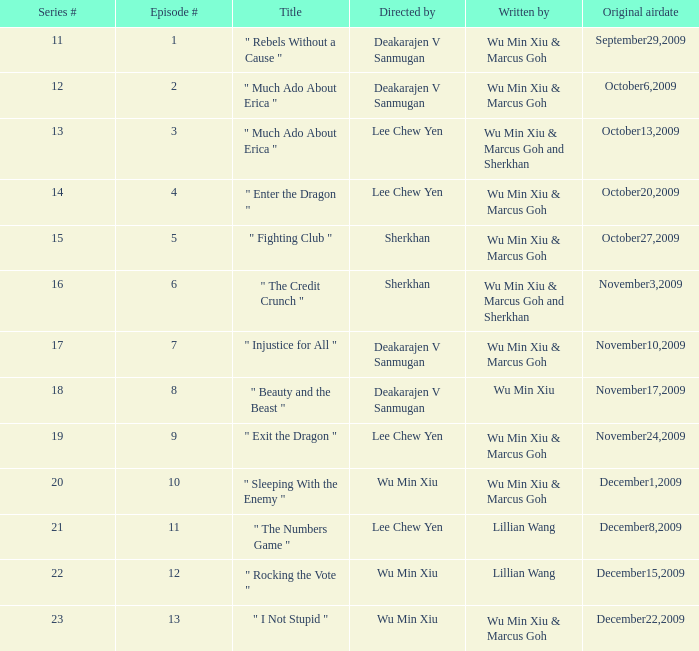What is the episode number for series 17? 7.0. 